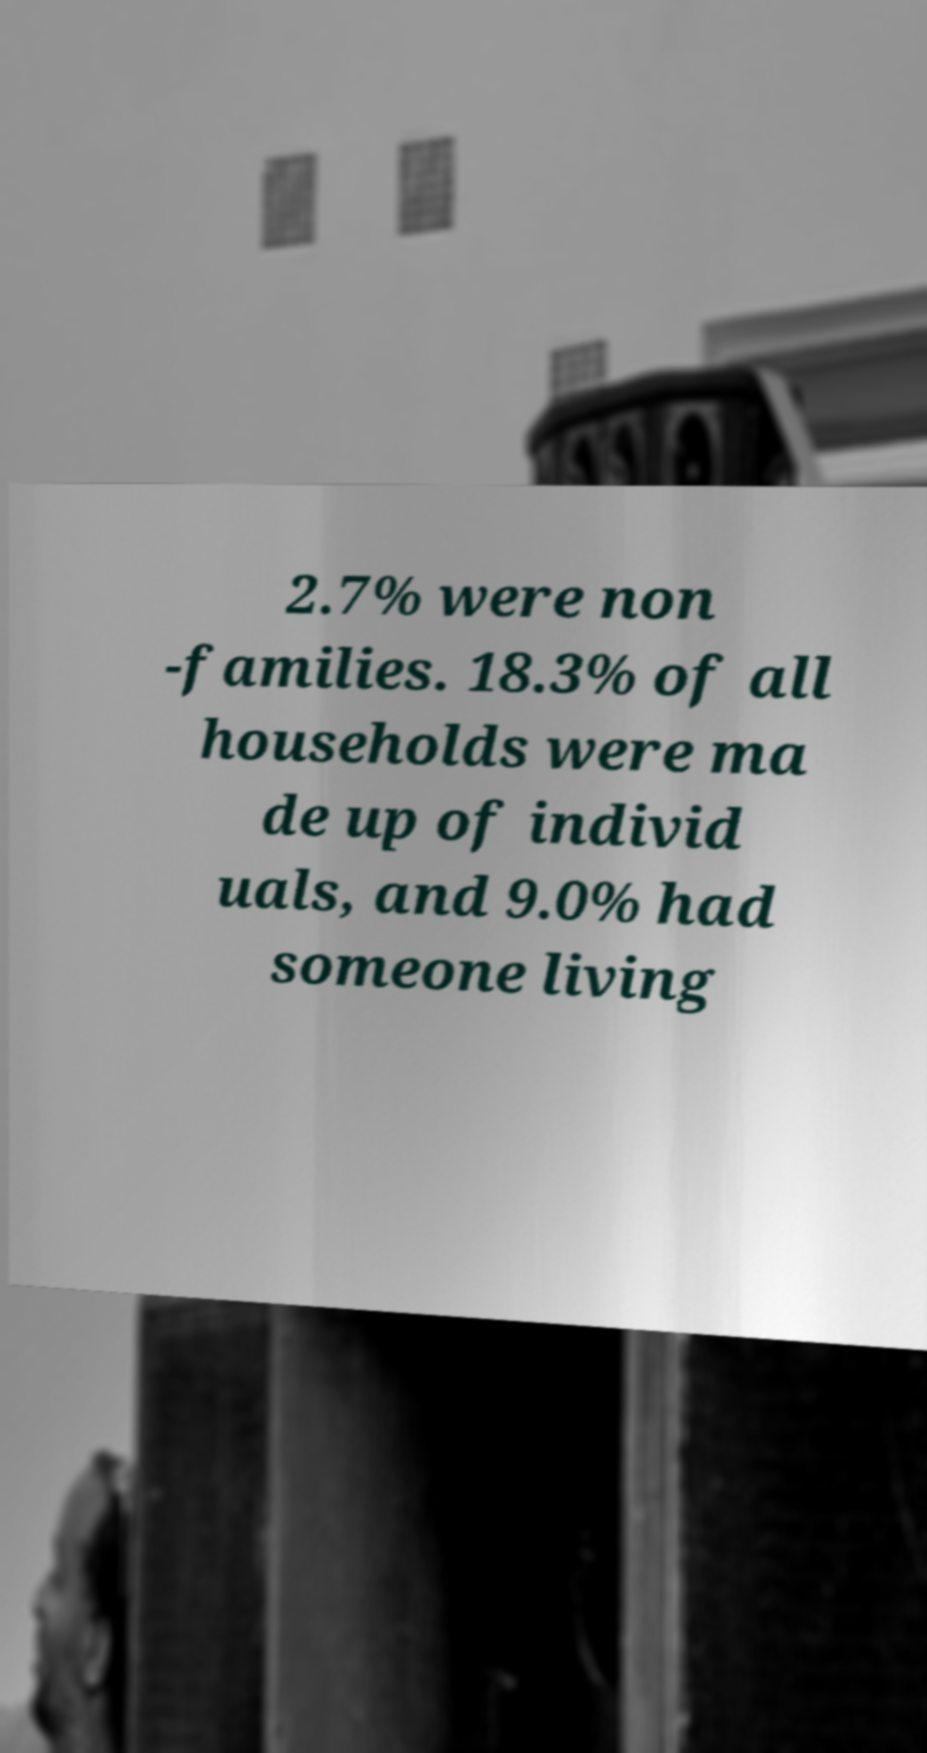Can you accurately transcribe the text from the provided image for me? 2.7% were non -families. 18.3% of all households were ma de up of individ uals, and 9.0% had someone living 